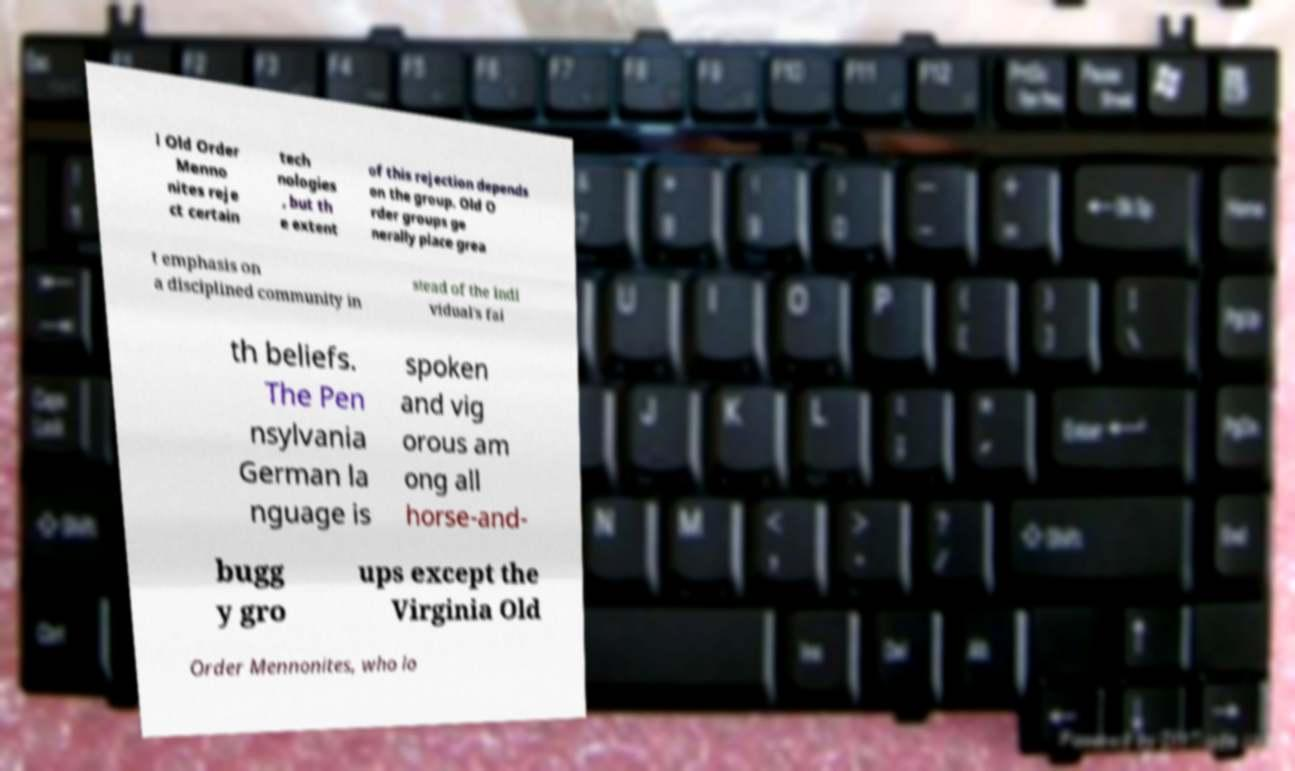Could you assist in decoding the text presented in this image and type it out clearly? l Old Order Menno nites reje ct certain tech nologies , but th e extent of this rejection depends on the group. Old O rder groups ge nerally place grea t emphasis on a disciplined community in stead of the indi vidual's fai th beliefs. The Pen nsylvania German la nguage is spoken and vig orous am ong all horse-and- bugg y gro ups except the Virginia Old Order Mennonites, who lo 